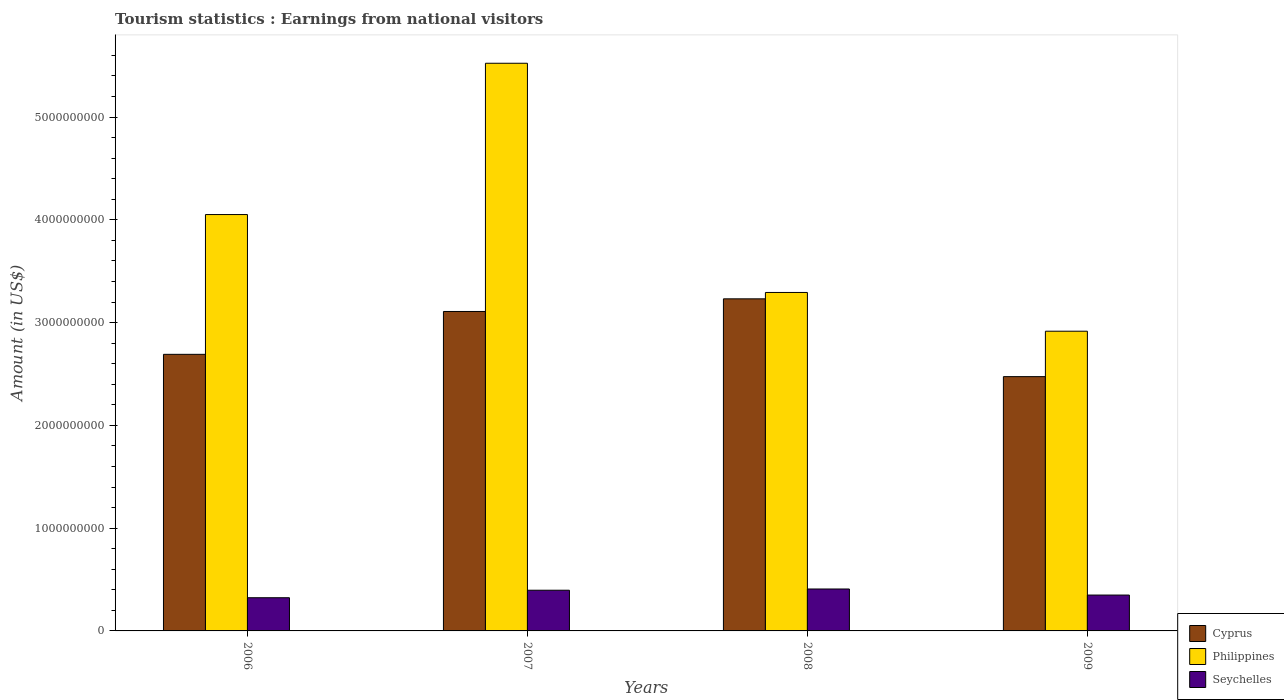How many different coloured bars are there?
Make the answer very short. 3. Are the number of bars per tick equal to the number of legend labels?
Offer a very short reply. Yes. Are the number of bars on each tick of the X-axis equal?
Ensure brevity in your answer.  Yes. How many bars are there on the 3rd tick from the left?
Give a very brief answer. 3. In how many cases, is the number of bars for a given year not equal to the number of legend labels?
Give a very brief answer. 0. What is the earnings from national visitors in Seychelles in 2008?
Offer a terse response. 4.08e+08. Across all years, what is the maximum earnings from national visitors in Cyprus?
Give a very brief answer. 3.23e+09. Across all years, what is the minimum earnings from national visitors in Philippines?
Make the answer very short. 2.92e+09. In which year was the earnings from national visitors in Cyprus minimum?
Your answer should be very brief. 2009. What is the total earnings from national visitors in Cyprus in the graph?
Keep it short and to the point. 1.15e+1. What is the difference between the earnings from national visitors in Seychelles in 2006 and that in 2007?
Ensure brevity in your answer.  -7.30e+07. What is the difference between the earnings from national visitors in Seychelles in 2008 and the earnings from national visitors in Philippines in 2009?
Keep it short and to the point. -2.51e+09. What is the average earnings from national visitors in Cyprus per year?
Provide a succinct answer. 2.88e+09. In the year 2007, what is the difference between the earnings from national visitors in Philippines and earnings from national visitors in Seychelles?
Provide a succinct answer. 5.13e+09. In how many years, is the earnings from national visitors in Cyprus greater than 2000000000 US$?
Your answer should be very brief. 4. What is the ratio of the earnings from national visitors in Seychelles in 2007 to that in 2009?
Keep it short and to the point. 1.13. Is the difference between the earnings from national visitors in Philippines in 2007 and 2009 greater than the difference between the earnings from national visitors in Seychelles in 2007 and 2009?
Your answer should be compact. Yes. What is the difference between the highest and the second highest earnings from national visitors in Cyprus?
Provide a short and direct response. 1.23e+08. What is the difference between the highest and the lowest earnings from national visitors in Philippines?
Your response must be concise. 2.61e+09. Is the sum of the earnings from national visitors in Cyprus in 2007 and 2009 greater than the maximum earnings from national visitors in Seychelles across all years?
Give a very brief answer. Yes. What does the 1st bar from the left in 2008 represents?
Give a very brief answer. Cyprus. Where does the legend appear in the graph?
Ensure brevity in your answer.  Bottom right. How many legend labels are there?
Make the answer very short. 3. What is the title of the graph?
Offer a terse response. Tourism statistics : Earnings from national visitors. What is the label or title of the X-axis?
Provide a succinct answer. Years. What is the Amount (in US$) of Cyprus in 2006?
Offer a terse response. 2.69e+09. What is the Amount (in US$) in Philippines in 2006?
Offer a very short reply. 4.05e+09. What is the Amount (in US$) of Seychelles in 2006?
Offer a very short reply. 3.23e+08. What is the Amount (in US$) of Cyprus in 2007?
Your answer should be very brief. 3.11e+09. What is the Amount (in US$) in Philippines in 2007?
Give a very brief answer. 5.52e+09. What is the Amount (in US$) of Seychelles in 2007?
Your response must be concise. 3.96e+08. What is the Amount (in US$) of Cyprus in 2008?
Your response must be concise. 3.23e+09. What is the Amount (in US$) of Philippines in 2008?
Your response must be concise. 3.29e+09. What is the Amount (in US$) in Seychelles in 2008?
Offer a terse response. 4.08e+08. What is the Amount (in US$) in Cyprus in 2009?
Offer a very short reply. 2.47e+09. What is the Amount (in US$) of Philippines in 2009?
Give a very brief answer. 2.92e+09. What is the Amount (in US$) in Seychelles in 2009?
Offer a terse response. 3.49e+08. Across all years, what is the maximum Amount (in US$) in Cyprus?
Your response must be concise. 3.23e+09. Across all years, what is the maximum Amount (in US$) in Philippines?
Keep it short and to the point. 5.52e+09. Across all years, what is the maximum Amount (in US$) of Seychelles?
Provide a short and direct response. 4.08e+08. Across all years, what is the minimum Amount (in US$) in Cyprus?
Offer a terse response. 2.47e+09. Across all years, what is the minimum Amount (in US$) in Philippines?
Offer a very short reply. 2.92e+09. Across all years, what is the minimum Amount (in US$) in Seychelles?
Give a very brief answer. 3.23e+08. What is the total Amount (in US$) in Cyprus in the graph?
Your response must be concise. 1.15e+1. What is the total Amount (in US$) in Philippines in the graph?
Give a very brief answer. 1.58e+1. What is the total Amount (in US$) of Seychelles in the graph?
Your answer should be very brief. 1.48e+09. What is the difference between the Amount (in US$) in Cyprus in 2006 and that in 2007?
Your response must be concise. -4.17e+08. What is the difference between the Amount (in US$) in Philippines in 2006 and that in 2007?
Your answer should be very brief. -1.47e+09. What is the difference between the Amount (in US$) of Seychelles in 2006 and that in 2007?
Your response must be concise. -7.30e+07. What is the difference between the Amount (in US$) of Cyprus in 2006 and that in 2008?
Offer a very short reply. -5.40e+08. What is the difference between the Amount (in US$) of Philippines in 2006 and that in 2008?
Ensure brevity in your answer.  7.58e+08. What is the difference between the Amount (in US$) in Seychelles in 2006 and that in 2008?
Offer a very short reply. -8.50e+07. What is the difference between the Amount (in US$) of Cyprus in 2006 and that in 2009?
Make the answer very short. 2.17e+08. What is the difference between the Amount (in US$) of Philippines in 2006 and that in 2009?
Offer a terse response. 1.14e+09. What is the difference between the Amount (in US$) of Seychelles in 2006 and that in 2009?
Provide a succinct answer. -2.60e+07. What is the difference between the Amount (in US$) in Cyprus in 2007 and that in 2008?
Offer a very short reply. -1.23e+08. What is the difference between the Amount (in US$) of Philippines in 2007 and that in 2008?
Give a very brief answer. 2.23e+09. What is the difference between the Amount (in US$) of Seychelles in 2007 and that in 2008?
Your answer should be compact. -1.20e+07. What is the difference between the Amount (in US$) of Cyprus in 2007 and that in 2009?
Provide a short and direct response. 6.34e+08. What is the difference between the Amount (in US$) in Philippines in 2007 and that in 2009?
Give a very brief answer. 2.61e+09. What is the difference between the Amount (in US$) of Seychelles in 2007 and that in 2009?
Your answer should be very brief. 4.70e+07. What is the difference between the Amount (in US$) in Cyprus in 2008 and that in 2009?
Your answer should be very brief. 7.57e+08. What is the difference between the Amount (in US$) in Philippines in 2008 and that in 2009?
Your answer should be compact. 3.77e+08. What is the difference between the Amount (in US$) of Seychelles in 2008 and that in 2009?
Ensure brevity in your answer.  5.90e+07. What is the difference between the Amount (in US$) of Cyprus in 2006 and the Amount (in US$) of Philippines in 2007?
Offer a very short reply. -2.83e+09. What is the difference between the Amount (in US$) in Cyprus in 2006 and the Amount (in US$) in Seychelles in 2007?
Offer a very short reply. 2.30e+09. What is the difference between the Amount (in US$) of Philippines in 2006 and the Amount (in US$) of Seychelles in 2007?
Offer a very short reply. 3.66e+09. What is the difference between the Amount (in US$) in Cyprus in 2006 and the Amount (in US$) in Philippines in 2008?
Keep it short and to the point. -6.02e+08. What is the difference between the Amount (in US$) of Cyprus in 2006 and the Amount (in US$) of Seychelles in 2008?
Your response must be concise. 2.28e+09. What is the difference between the Amount (in US$) in Philippines in 2006 and the Amount (in US$) in Seychelles in 2008?
Provide a short and direct response. 3.64e+09. What is the difference between the Amount (in US$) of Cyprus in 2006 and the Amount (in US$) of Philippines in 2009?
Provide a short and direct response. -2.25e+08. What is the difference between the Amount (in US$) in Cyprus in 2006 and the Amount (in US$) in Seychelles in 2009?
Your response must be concise. 2.34e+09. What is the difference between the Amount (in US$) in Philippines in 2006 and the Amount (in US$) in Seychelles in 2009?
Keep it short and to the point. 3.70e+09. What is the difference between the Amount (in US$) of Cyprus in 2007 and the Amount (in US$) of Philippines in 2008?
Provide a succinct answer. -1.85e+08. What is the difference between the Amount (in US$) of Cyprus in 2007 and the Amount (in US$) of Seychelles in 2008?
Give a very brief answer. 2.70e+09. What is the difference between the Amount (in US$) in Philippines in 2007 and the Amount (in US$) in Seychelles in 2008?
Ensure brevity in your answer.  5.12e+09. What is the difference between the Amount (in US$) of Cyprus in 2007 and the Amount (in US$) of Philippines in 2009?
Provide a short and direct response. 1.92e+08. What is the difference between the Amount (in US$) of Cyprus in 2007 and the Amount (in US$) of Seychelles in 2009?
Keep it short and to the point. 2.76e+09. What is the difference between the Amount (in US$) of Philippines in 2007 and the Amount (in US$) of Seychelles in 2009?
Provide a succinct answer. 5.17e+09. What is the difference between the Amount (in US$) of Cyprus in 2008 and the Amount (in US$) of Philippines in 2009?
Provide a short and direct response. 3.15e+08. What is the difference between the Amount (in US$) of Cyprus in 2008 and the Amount (in US$) of Seychelles in 2009?
Your answer should be very brief. 2.88e+09. What is the difference between the Amount (in US$) in Philippines in 2008 and the Amount (in US$) in Seychelles in 2009?
Provide a short and direct response. 2.94e+09. What is the average Amount (in US$) in Cyprus per year?
Your answer should be very brief. 2.88e+09. What is the average Amount (in US$) of Philippines per year?
Provide a succinct answer. 3.95e+09. What is the average Amount (in US$) of Seychelles per year?
Offer a very short reply. 3.69e+08. In the year 2006, what is the difference between the Amount (in US$) of Cyprus and Amount (in US$) of Philippines?
Give a very brief answer. -1.36e+09. In the year 2006, what is the difference between the Amount (in US$) of Cyprus and Amount (in US$) of Seychelles?
Keep it short and to the point. 2.37e+09. In the year 2006, what is the difference between the Amount (in US$) of Philippines and Amount (in US$) of Seychelles?
Provide a short and direct response. 3.73e+09. In the year 2007, what is the difference between the Amount (in US$) of Cyprus and Amount (in US$) of Philippines?
Keep it short and to the point. -2.42e+09. In the year 2007, what is the difference between the Amount (in US$) of Cyprus and Amount (in US$) of Seychelles?
Your response must be concise. 2.71e+09. In the year 2007, what is the difference between the Amount (in US$) in Philippines and Amount (in US$) in Seychelles?
Your answer should be very brief. 5.13e+09. In the year 2008, what is the difference between the Amount (in US$) in Cyprus and Amount (in US$) in Philippines?
Your answer should be compact. -6.20e+07. In the year 2008, what is the difference between the Amount (in US$) of Cyprus and Amount (in US$) of Seychelles?
Provide a short and direct response. 2.82e+09. In the year 2008, what is the difference between the Amount (in US$) in Philippines and Amount (in US$) in Seychelles?
Offer a terse response. 2.88e+09. In the year 2009, what is the difference between the Amount (in US$) of Cyprus and Amount (in US$) of Philippines?
Provide a short and direct response. -4.42e+08. In the year 2009, what is the difference between the Amount (in US$) of Cyprus and Amount (in US$) of Seychelles?
Provide a succinct answer. 2.12e+09. In the year 2009, what is the difference between the Amount (in US$) in Philippines and Amount (in US$) in Seychelles?
Your answer should be very brief. 2.57e+09. What is the ratio of the Amount (in US$) of Cyprus in 2006 to that in 2007?
Ensure brevity in your answer.  0.87. What is the ratio of the Amount (in US$) of Philippines in 2006 to that in 2007?
Ensure brevity in your answer.  0.73. What is the ratio of the Amount (in US$) of Seychelles in 2006 to that in 2007?
Ensure brevity in your answer.  0.82. What is the ratio of the Amount (in US$) in Cyprus in 2006 to that in 2008?
Your answer should be very brief. 0.83. What is the ratio of the Amount (in US$) in Philippines in 2006 to that in 2008?
Provide a short and direct response. 1.23. What is the ratio of the Amount (in US$) in Seychelles in 2006 to that in 2008?
Offer a terse response. 0.79. What is the ratio of the Amount (in US$) in Cyprus in 2006 to that in 2009?
Keep it short and to the point. 1.09. What is the ratio of the Amount (in US$) in Philippines in 2006 to that in 2009?
Offer a terse response. 1.39. What is the ratio of the Amount (in US$) of Seychelles in 2006 to that in 2009?
Your answer should be very brief. 0.93. What is the ratio of the Amount (in US$) of Cyprus in 2007 to that in 2008?
Give a very brief answer. 0.96. What is the ratio of the Amount (in US$) of Philippines in 2007 to that in 2008?
Your response must be concise. 1.68. What is the ratio of the Amount (in US$) of Seychelles in 2007 to that in 2008?
Ensure brevity in your answer.  0.97. What is the ratio of the Amount (in US$) of Cyprus in 2007 to that in 2009?
Provide a short and direct response. 1.26. What is the ratio of the Amount (in US$) in Philippines in 2007 to that in 2009?
Provide a short and direct response. 1.89. What is the ratio of the Amount (in US$) in Seychelles in 2007 to that in 2009?
Give a very brief answer. 1.13. What is the ratio of the Amount (in US$) of Cyprus in 2008 to that in 2009?
Ensure brevity in your answer.  1.31. What is the ratio of the Amount (in US$) of Philippines in 2008 to that in 2009?
Your answer should be compact. 1.13. What is the ratio of the Amount (in US$) in Seychelles in 2008 to that in 2009?
Your answer should be compact. 1.17. What is the difference between the highest and the second highest Amount (in US$) of Cyprus?
Provide a succinct answer. 1.23e+08. What is the difference between the highest and the second highest Amount (in US$) in Philippines?
Offer a very short reply. 1.47e+09. What is the difference between the highest and the second highest Amount (in US$) of Seychelles?
Your answer should be compact. 1.20e+07. What is the difference between the highest and the lowest Amount (in US$) of Cyprus?
Give a very brief answer. 7.57e+08. What is the difference between the highest and the lowest Amount (in US$) in Philippines?
Provide a short and direct response. 2.61e+09. What is the difference between the highest and the lowest Amount (in US$) in Seychelles?
Offer a very short reply. 8.50e+07. 